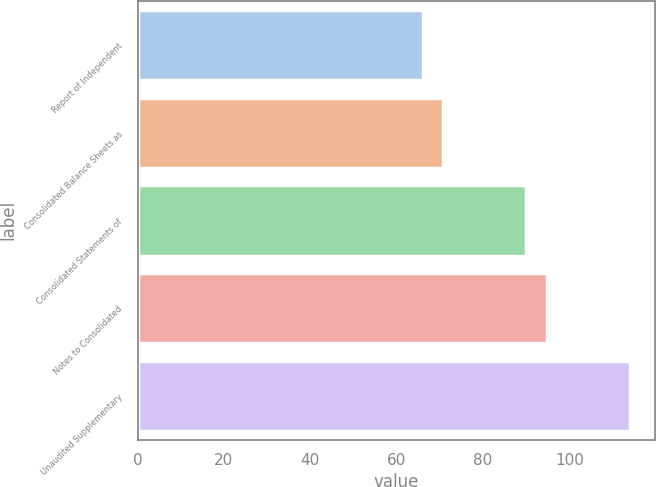Convert chart to OTSL. <chart><loc_0><loc_0><loc_500><loc_500><bar_chart><fcel>Report of Independent<fcel>Consolidated Balance Sheets as<fcel>Consolidated Statements of<fcel>Notes to Consolidated<fcel>Unaudited Supplementary<nl><fcel>66<fcel>70.8<fcel>90<fcel>94.8<fcel>114<nl></chart> 